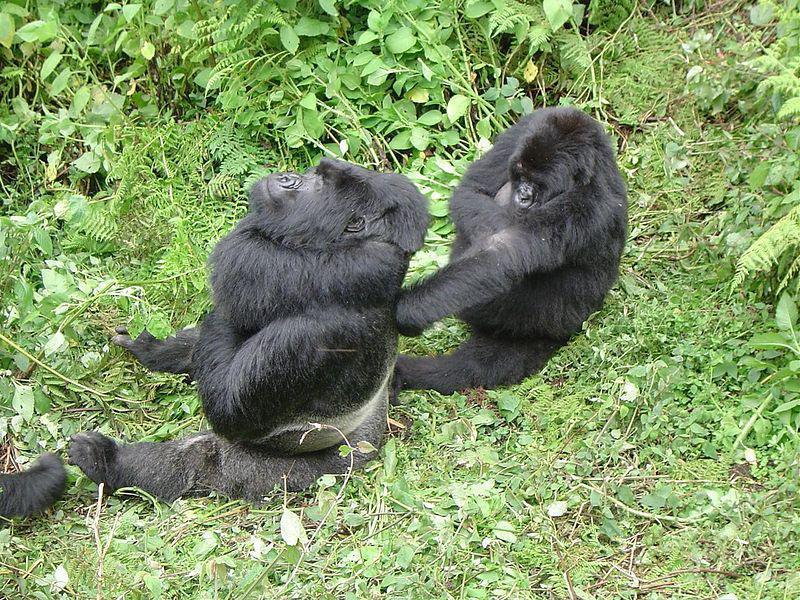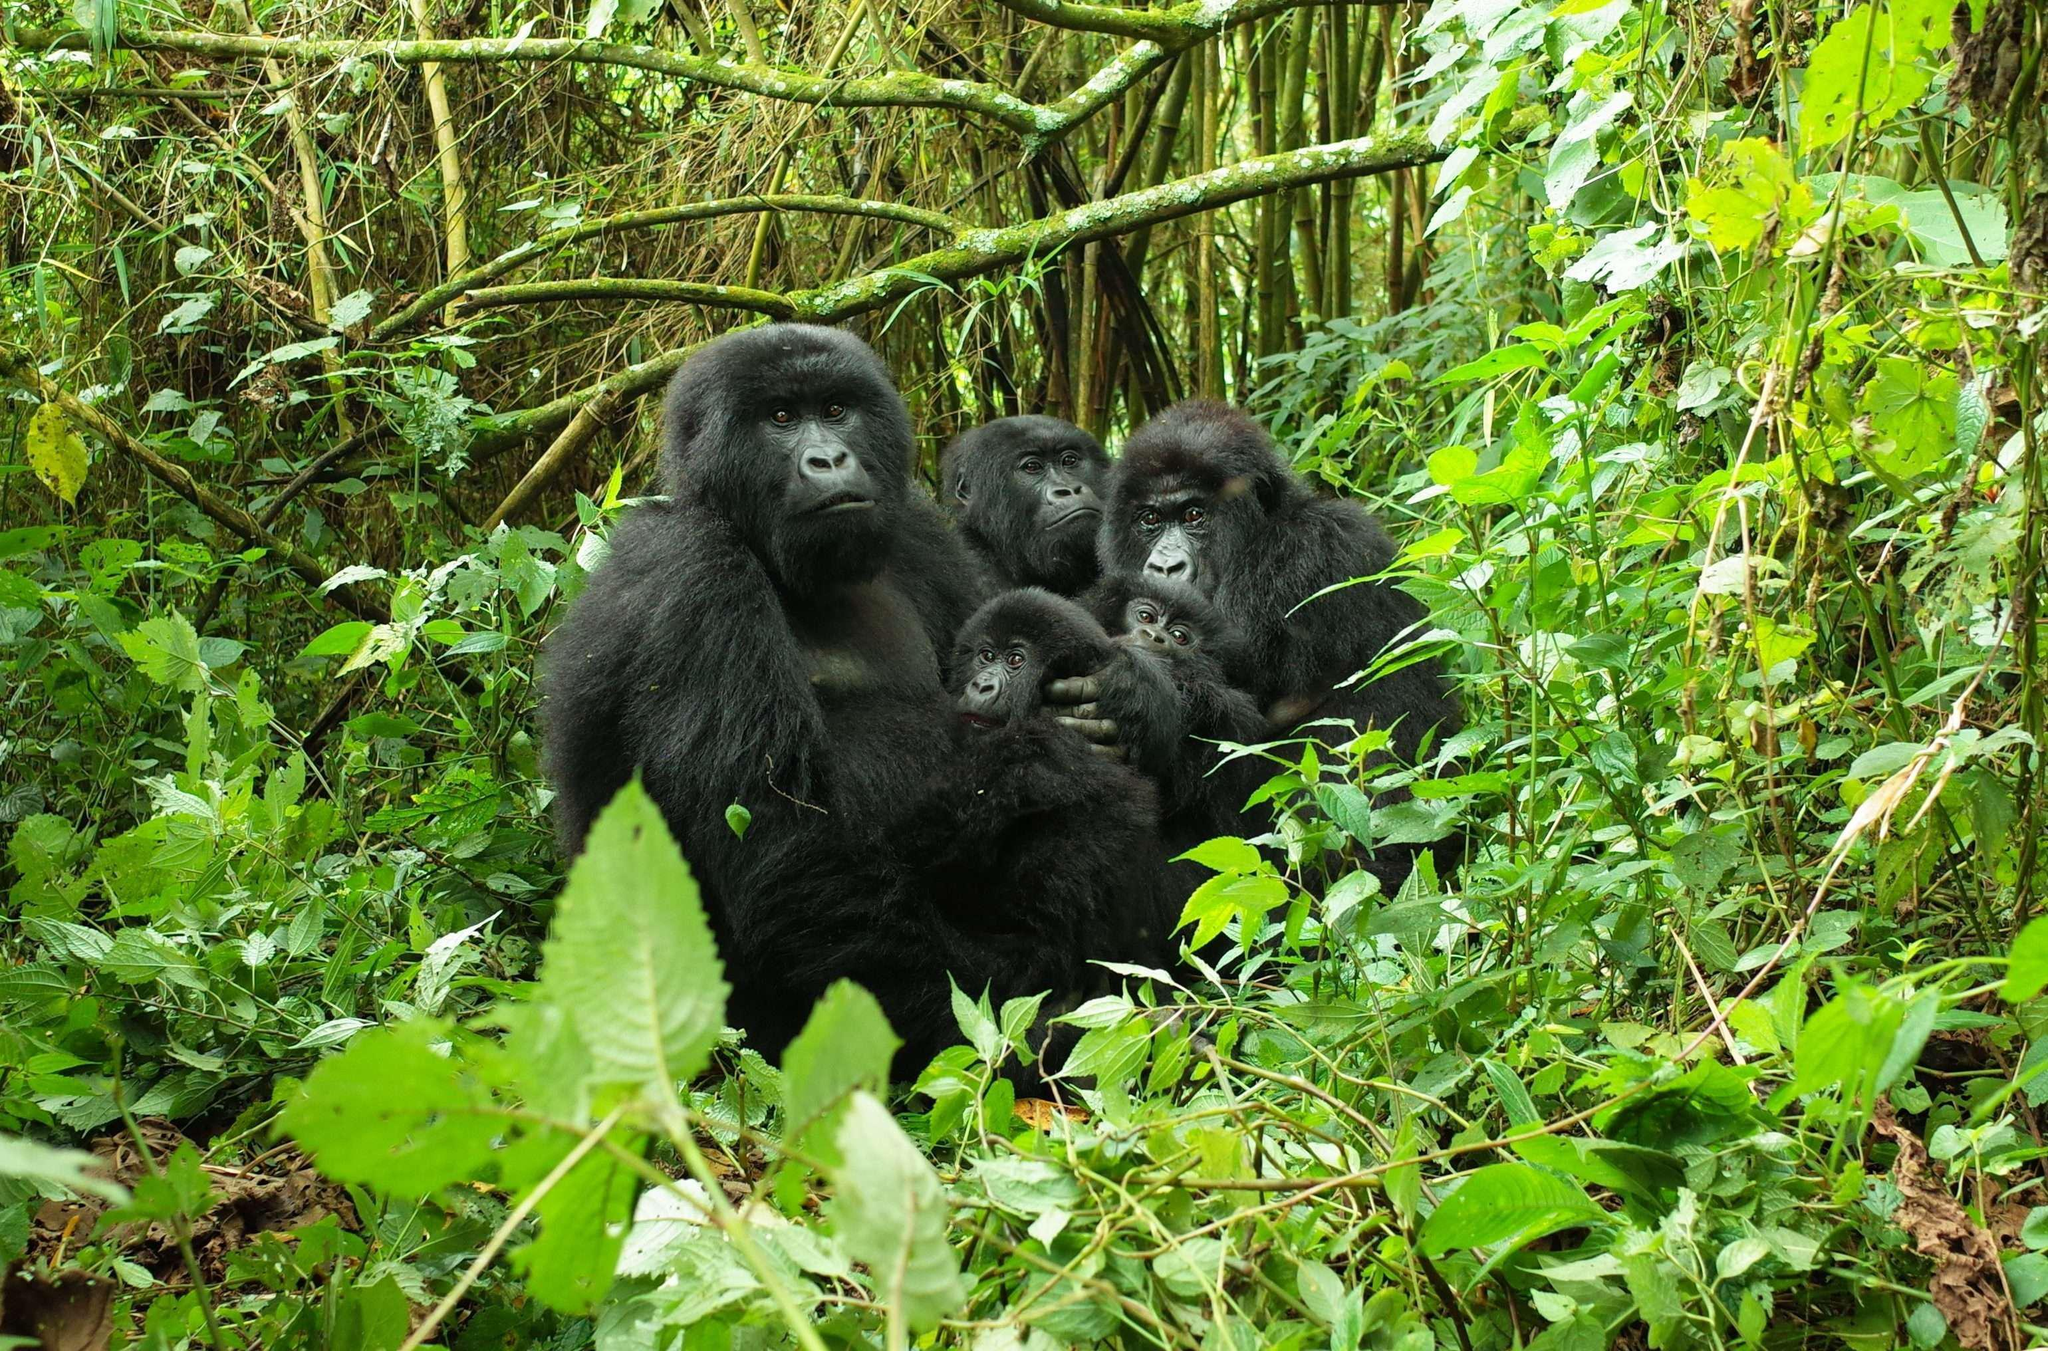The first image is the image on the left, the second image is the image on the right. For the images displayed, is the sentence "An image contains exactly two gorillas, and one is behind the other facing its back but not riding on its back." factually correct? Answer yes or no. Yes. The first image is the image on the left, the second image is the image on the right. For the images shown, is this caption "The left image contains exactly two gorillas." true? Answer yes or no. Yes. 